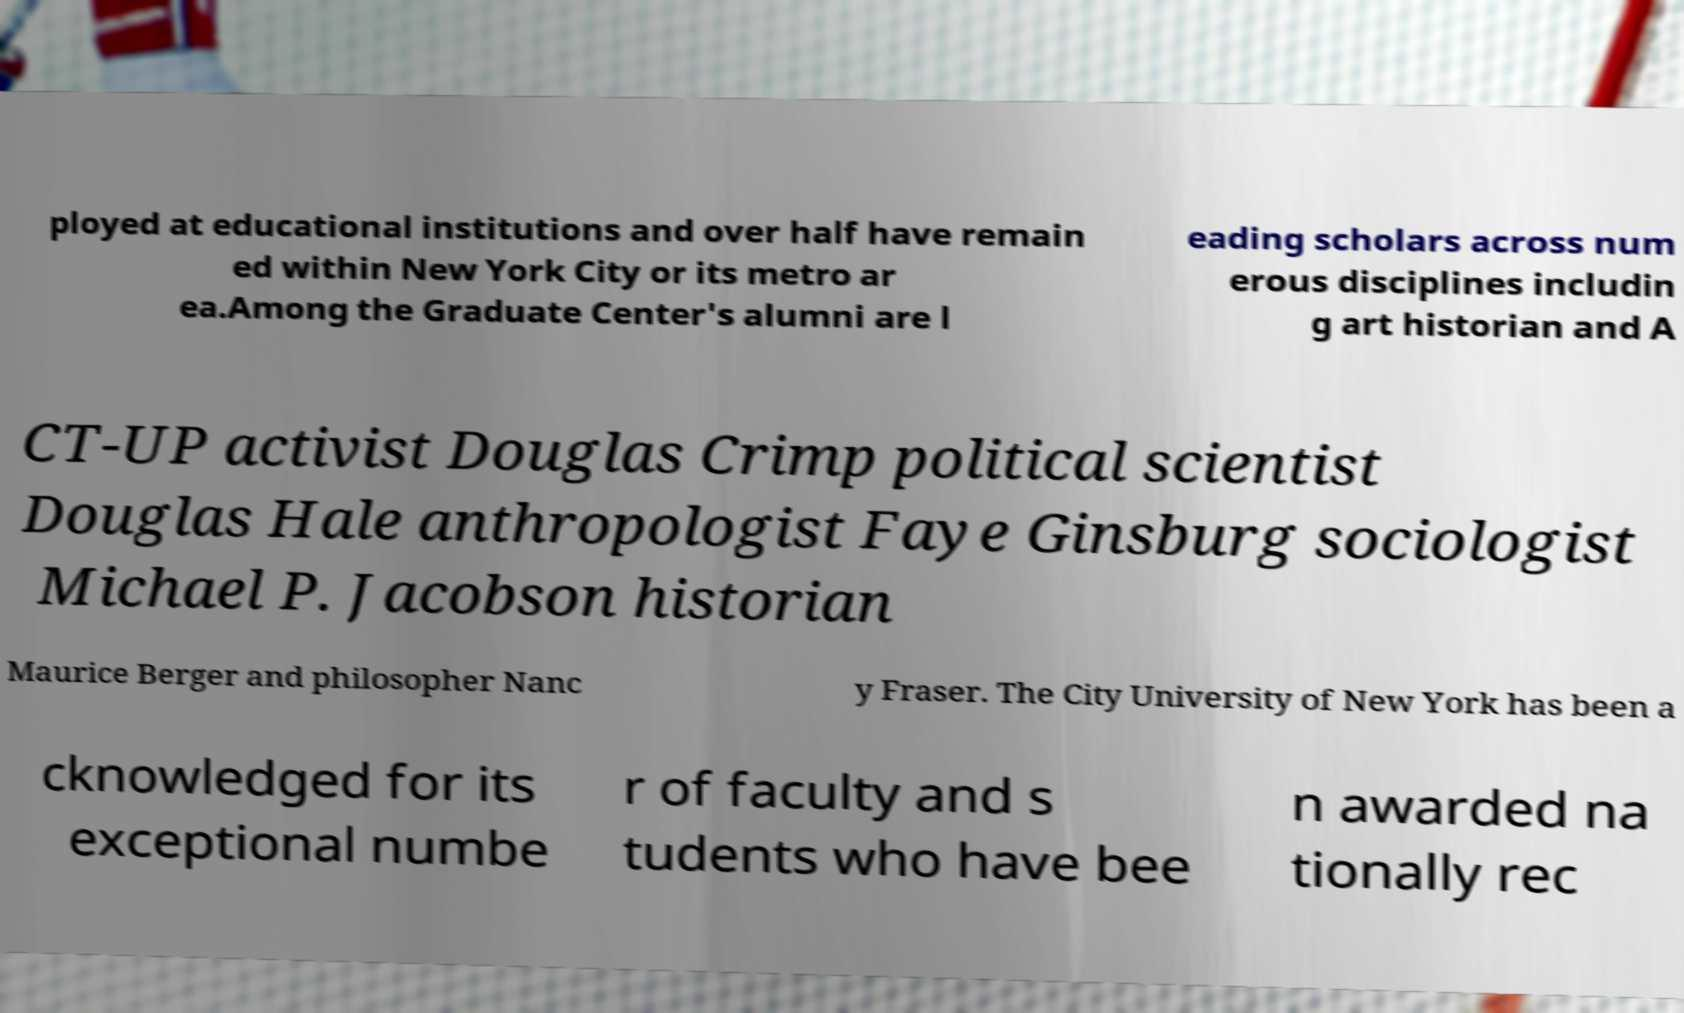Can you accurately transcribe the text from the provided image for me? ployed at educational institutions and over half have remain ed within New York City or its metro ar ea.Among the Graduate Center's alumni are l eading scholars across num erous disciplines includin g art historian and A CT-UP activist Douglas Crimp political scientist Douglas Hale anthropologist Faye Ginsburg sociologist Michael P. Jacobson historian Maurice Berger and philosopher Nanc y Fraser. The City University of New York has been a cknowledged for its exceptional numbe r of faculty and s tudents who have bee n awarded na tionally rec 